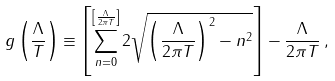Convert formula to latex. <formula><loc_0><loc_0><loc_500><loc_500>g \left ( \frac { \Lambda } { T } \right ) \equiv \left [ \sum _ { n = 0 } ^ { \left [ \frac { \Lambda } { 2 \pi T } \right ] } 2 \sqrt { \left ( \frac { \Lambda } { 2 \pi T } \right ) ^ { 2 } - n ^ { 2 } } \right ] - \frac { \Lambda } { 2 \pi T } \, ,</formula> 